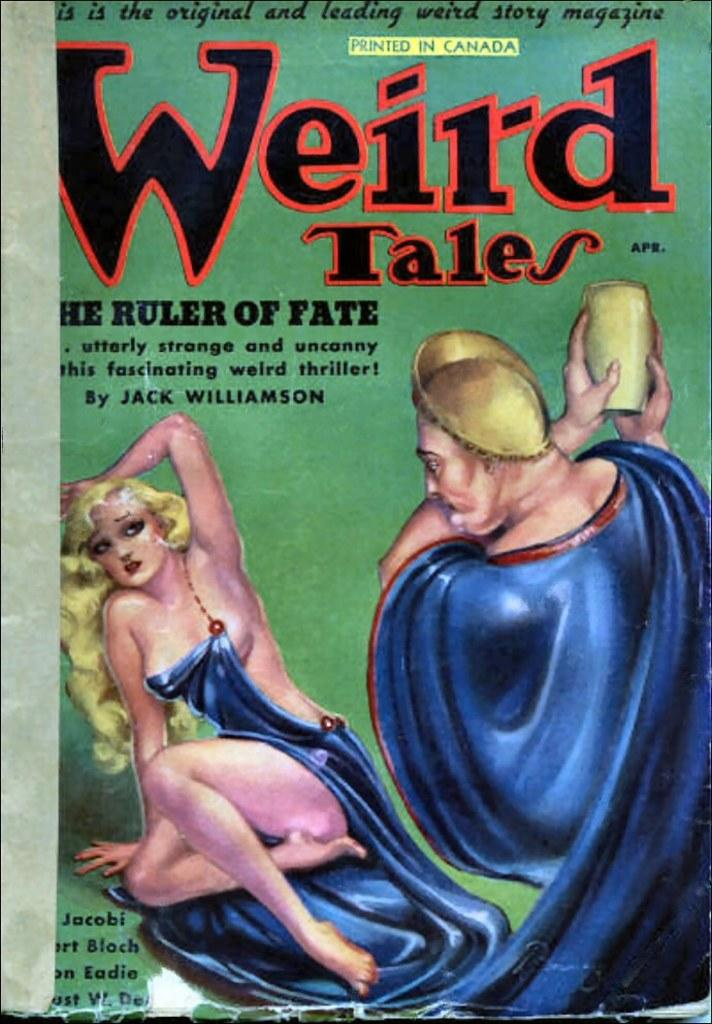What is featured in the image? There is a poster in the image. What can be found on the poster? There is text on the poster. What color is the background of the image? The background color of the image is green. Can you tell me how many frogs are depicted on the poster? There is no frog present on the poster; it only features text. What type of art is displayed on the top of the poster? There is no art displayed on the poster, as it only contains text. 